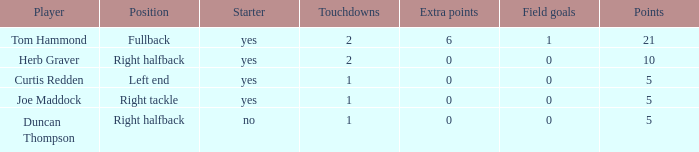I'm looking to parse the entire table for insights. Could you assist me with that? {'header': ['Player', 'Position', 'Starter', 'Touchdowns', 'Extra points', 'Field goals', 'Points'], 'rows': [['Tom Hammond', 'Fullback', 'yes', '2', '6', '1', '21'], ['Herb Graver', 'Right halfback', 'yes', '2', '0', '0', '10'], ['Curtis Redden', 'Left end', 'yes', '1', '0', '0', '5'], ['Joe Maddock', 'Right tackle', 'yes', '1', '0', '0', '5'], ['Duncan Thompson', 'Right halfback', 'no', '1', '0', '0', '5']]} Which player is assigned as the starter for the left end role? Yes. 